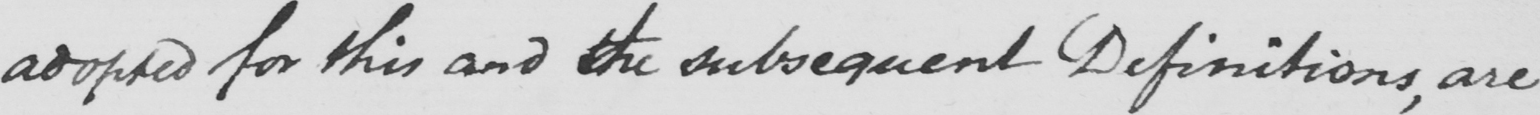Can you tell me what this handwritten text says? adopted for this and the subsequent Definitions , are 